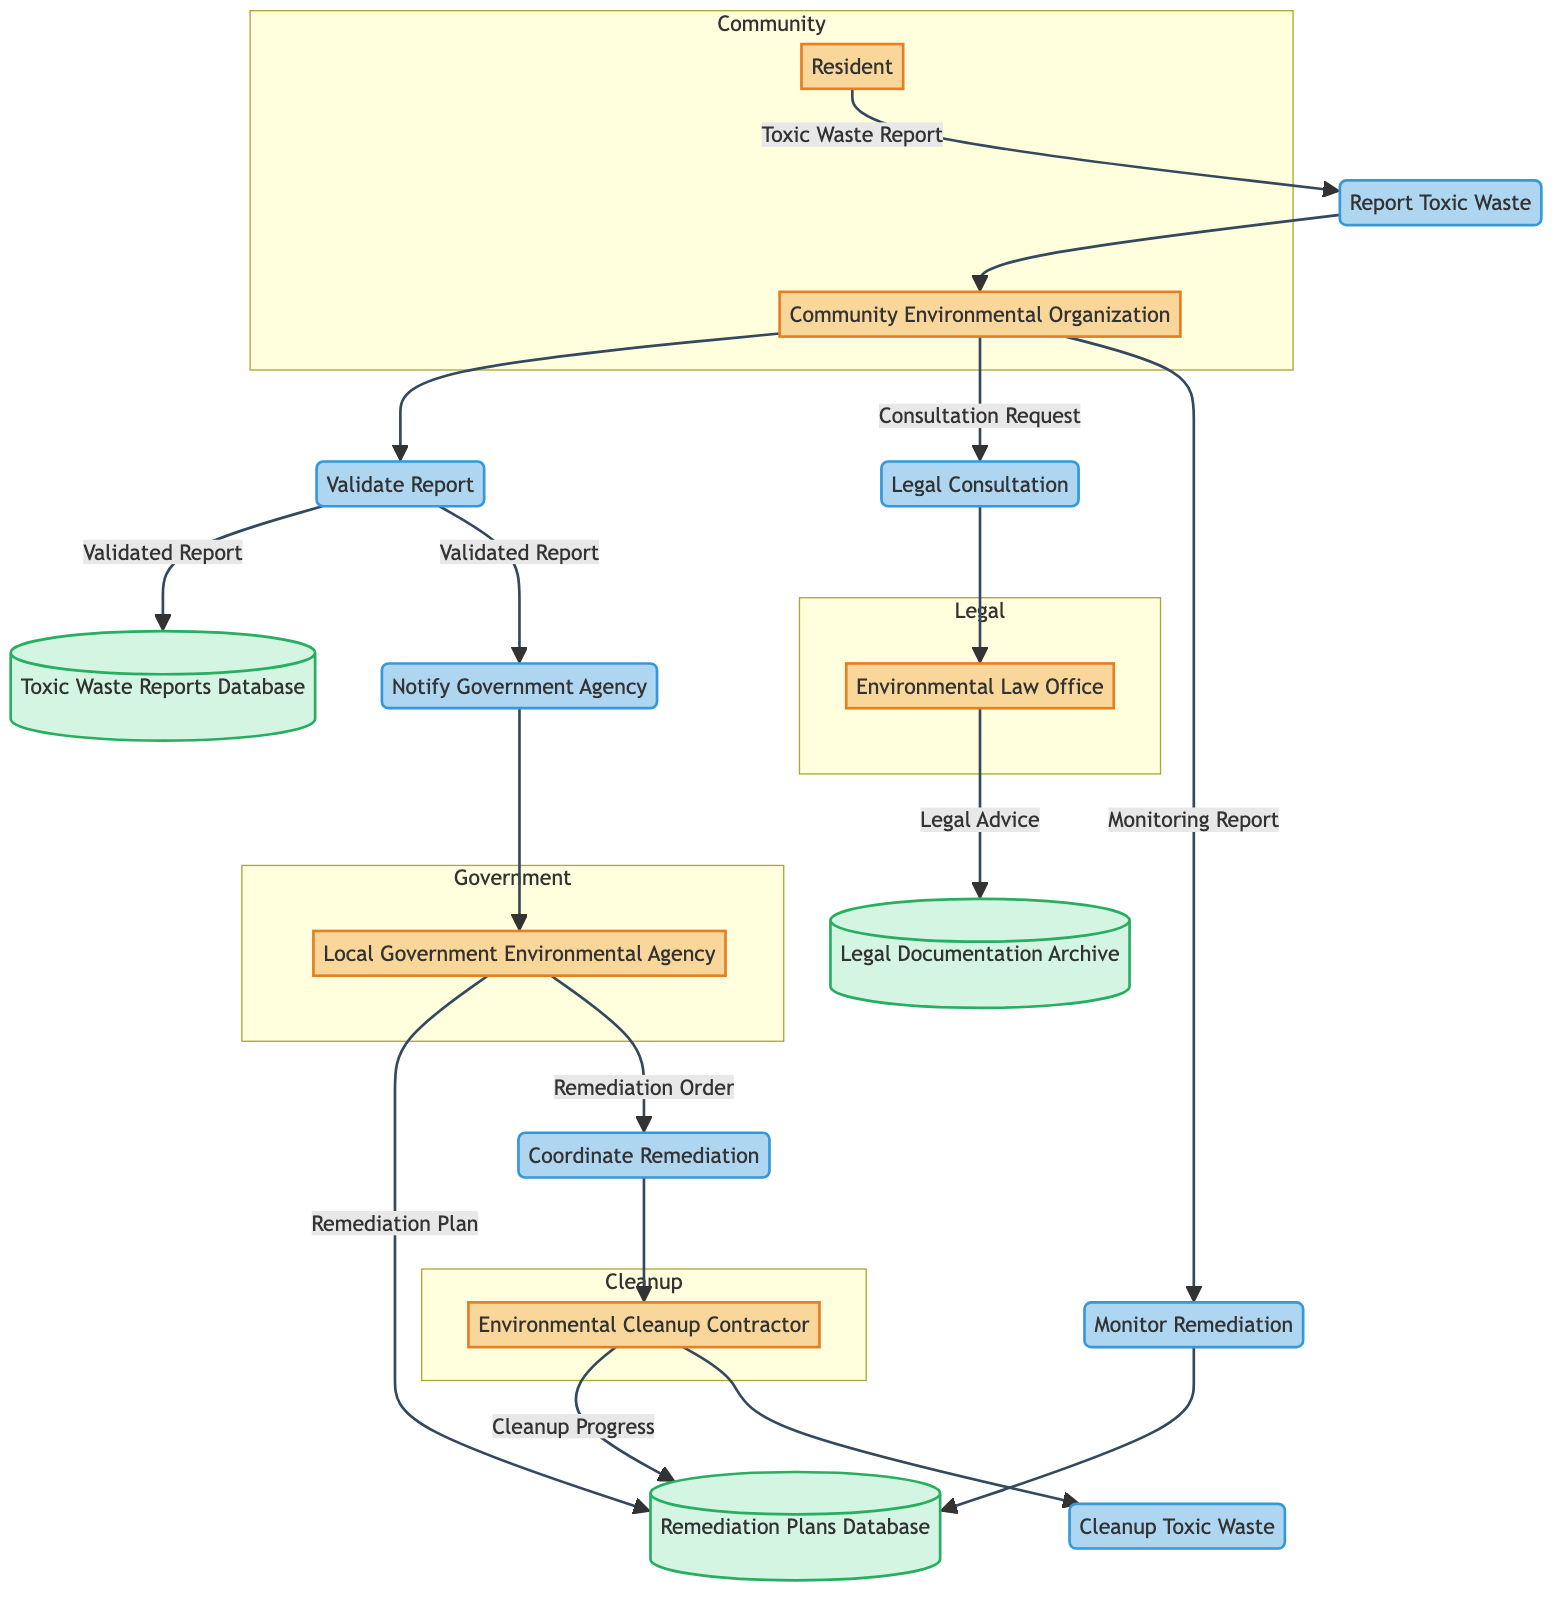What is the first process in the diagram? The first process shown in the diagram is "Report Toxic Waste," which receives reports from residents. This can be determined by tracing the flow from the "Resident" entity to the "Report Toxic Waste" process as the initiating step.
Answer: Report Toxic Waste How many entities are involved in the flow? By counting the entities listed in the diagram, we find there are five: Resident, Community Environmental Organization, Local Government Environmental Agency, Environmental Law Office, and Environmental Cleanup Contractor.
Answer: Five Which entity receives the validated report from the Community Environmental Organization? The validated report from the Community Environmental Organization is sent to both the Toxic Waste Reports Database and Local Government Environmental Agency. Identifying the outgoing flows from the CEO indicates these two destinations.
Answer: Local Government Environmental Agency What process follows after the "Cleanup Toxic Waste" process? The diagram does not show any processes that follow the "Cleanup Toxic Waste" process. Since this process is towards the end of the flow, it indicates the completion of the remediation actions.
Answer: None What documents are stored in the Legal Documentation Archive? The Legal Documentation Archive holds "Legal Advice" as indicated by the flow from the Environmental Law Office. This connection shows that legal advice is documented and stored in this archive.
Answer: Legal Advice How many data flows originate from the Community Environmental Organization? Counting all outgoing data flows from the Community Environmental Organization reveals there are four: to the Toxic Waste Reports Database, Local Government Environmental Agency, Environmental Law Office, and Remediation Plans Database.
Answer: Four Which database stores reports of toxic waste incidents? The "Toxic Waste Reports Database" specifically stores all reported incidents of toxic waste within the community as indicated in the diagram.
Answer: Toxic Waste Reports Database What is the role of the Environmental Cleanup Contractor according to the diagram? The Environmental Cleanup Contractor's role involves carrying out the "Cleanup Toxic Waste" process, and also they report "Cleanup Progress" back to the Remediation Plans Database. Both roles highlight their involvement in remediation efforts.
Answer: Cleanup Toxic Waste What must happen before a legal consultation is provided? Before legal consultation is provided by the Environmental Law Office, a "Consultation Request" must be sent from the Community Environmental Organization, indicating the need for legal support based on the reported toxic waste issues.
Answer: Consultation Request 